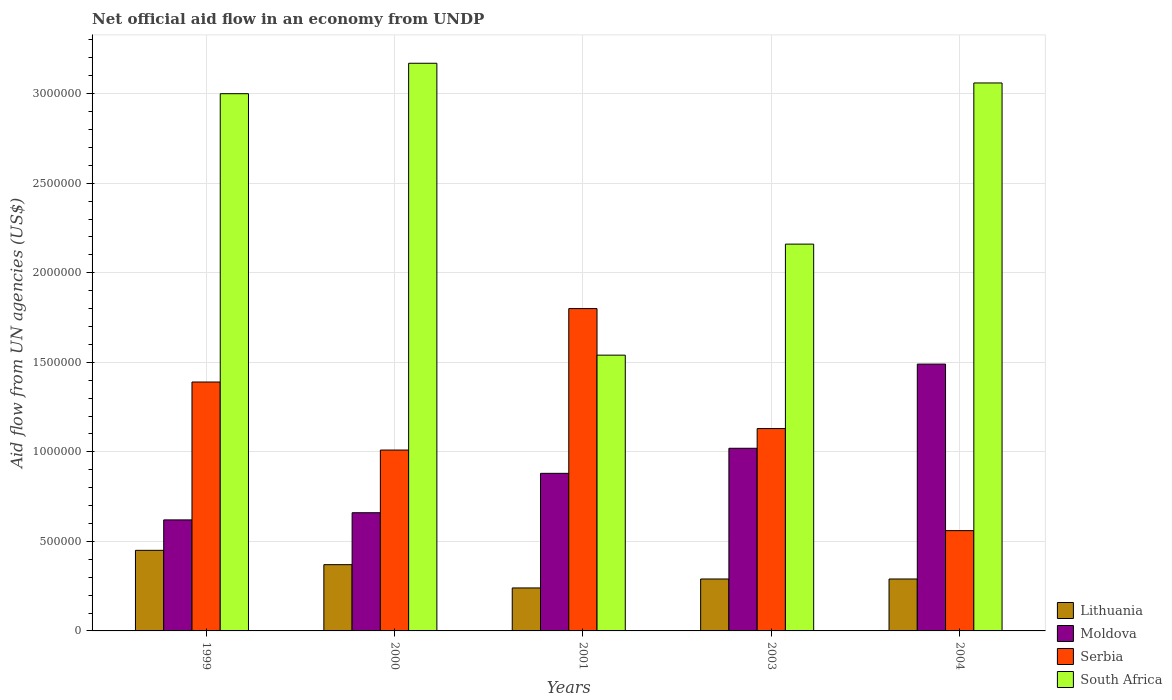How many groups of bars are there?
Ensure brevity in your answer.  5. Are the number of bars per tick equal to the number of legend labels?
Your answer should be compact. Yes. How many bars are there on the 5th tick from the left?
Keep it short and to the point. 4. How many bars are there on the 3rd tick from the right?
Ensure brevity in your answer.  4. What is the net official aid flow in Lithuania in 2003?
Make the answer very short. 2.90e+05. Across all years, what is the maximum net official aid flow in Moldova?
Make the answer very short. 1.49e+06. Across all years, what is the minimum net official aid flow in South Africa?
Your answer should be very brief. 1.54e+06. In which year was the net official aid flow in Lithuania maximum?
Ensure brevity in your answer.  1999. In which year was the net official aid flow in South Africa minimum?
Ensure brevity in your answer.  2001. What is the total net official aid flow in Moldova in the graph?
Your answer should be compact. 4.67e+06. What is the average net official aid flow in Serbia per year?
Provide a succinct answer. 1.18e+06. In the year 2003, what is the difference between the net official aid flow in South Africa and net official aid flow in Lithuania?
Your answer should be compact. 1.87e+06. What is the ratio of the net official aid flow in Lithuania in 2001 to that in 2004?
Offer a terse response. 0.83. Is the net official aid flow in Lithuania in 1999 less than that in 2004?
Give a very brief answer. No. What is the difference between the highest and the lowest net official aid flow in Serbia?
Provide a short and direct response. 1.24e+06. In how many years, is the net official aid flow in Serbia greater than the average net official aid flow in Serbia taken over all years?
Give a very brief answer. 2. What does the 2nd bar from the left in 1999 represents?
Keep it short and to the point. Moldova. What does the 3rd bar from the right in 2004 represents?
Your answer should be very brief. Moldova. Is it the case that in every year, the sum of the net official aid flow in South Africa and net official aid flow in Moldova is greater than the net official aid flow in Serbia?
Keep it short and to the point. Yes. Does the graph contain any zero values?
Your response must be concise. No. Where does the legend appear in the graph?
Keep it short and to the point. Bottom right. How many legend labels are there?
Make the answer very short. 4. What is the title of the graph?
Your response must be concise. Net official aid flow in an economy from UNDP. Does "Europe(all income levels)" appear as one of the legend labels in the graph?
Provide a succinct answer. No. What is the label or title of the Y-axis?
Your response must be concise. Aid flow from UN agencies (US$). What is the Aid flow from UN agencies (US$) in Lithuania in 1999?
Offer a terse response. 4.50e+05. What is the Aid flow from UN agencies (US$) of Moldova in 1999?
Offer a terse response. 6.20e+05. What is the Aid flow from UN agencies (US$) in Serbia in 1999?
Offer a very short reply. 1.39e+06. What is the Aid flow from UN agencies (US$) in Lithuania in 2000?
Keep it short and to the point. 3.70e+05. What is the Aid flow from UN agencies (US$) in Moldova in 2000?
Make the answer very short. 6.60e+05. What is the Aid flow from UN agencies (US$) of Serbia in 2000?
Provide a succinct answer. 1.01e+06. What is the Aid flow from UN agencies (US$) in South Africa in 2000?
Your response must be concise. 3.17e+06. What is the Aid flow from UN agencies (US$) in Lithuania in 2001?
Make the answer very short. 2.40e+05. What is the Aid flow from UN agencies (US$) of Moldova in 2001?
Provide a short and direct response. 8.80e+05. What is the Aid flow from UN agencies (US$) of Serbia in 2001?
Ensure brevity in your answer.  1.80e+06. What is the Aid flow from UN agencies (US$) of South Africa in 2001?
Offer a terse response. 1.54e+06. What is the Aid flow from UN agencies (US$) in Moldova in 2003?
Provide a succinct answer. 1.02e+06. What is the Aid flow from UN agencies (US$) in Serbia in 2003?
Your answer should be compact. 1.13e+06. What is the Aid flow from UN agencies (US$) of South Africa in 2003?
Offer a terse response. 2.16e+06. What is the Aid flow from UN agencies (US$) in Moldova in 2004?
Your response must be concise. 1.49e+06. What is the Aid flow from UN agencies (US$) of Serbia in 2004?
Make the answer very short. 5.60e+05. What is the Aid flow from UN agencies (US$) in South Africa in 2004?
Your answer should be compact. 3.06e+06. Across all years, what is the maximum Aid flow from UN agencies (US$) of Moldova?
Your answer should be compact. 1.49e+06. Across all years, what is the maximum Aid flow from UN agencies (US$) of Serbia?
Your answer should be compact. 1.80e+06. Across all years, what is the maximum Aid flow from UN agencies (US$) of South Africa?
Provide a short and direct response. 3.17e+06. Across all years, what is the minimum Aid flow from UN agencies (US$) in Lithuania?
Ensure brevity in your answer.  2.40e+05. Across all years, what is the minimum Aid flow from UN agencies (US$) of Moldova?
Keep it short and to the point. 6.20e+05. Across all years, what is the minimum Aid flow from UN agencies (US$) in Serbia?
Give a very brief answer. 5.60e+05. Across all years, what is the minimum Aid flow from UN agencies (US$) in South Africa?
Provide a short and direct response. 1.54e+06. What is the total Aid flow from UN agencies (US$) of Lithuania in the graph?
Give a very brief answer. 1.64e+06. What is the total Aid flow from UN agencies (US$) in Moldova in the graph?
Make the answer very short. 4.67e+06. What is the total Aid flow from UN agencies (US$) of Serbia in the graph?
Your answer should be very brief. 5.89e+06. What is the total Aid flow from UN agencies (US$) in South Africa in the graph?
Keep it short and to the point. 1.29e+07. What is the difference between the Aid flow from UN agencies (US$) in Serbia in 1999 and that in 2001?
Offer a very short reply. -4.10e+05. What is the difference between the Aid flow from UN agencies (US$) in South Africa in 1999 and that in 2001?
Provide a succinct answer. 1.46e+06. What is the difference between the Aid flow from UN agencies (US$) in Moldova in 1999 and that in 2003?
Offer a terse response. -4.00e+05. What is the difference between the Aid flow from UN agencies (US$) of South Africa in 1999 and that in 2003?
Give a very brief answer. 8.40e+05. What is the difference between the Aid flow from UN agencies (US$) in Moldova in 1999 and that in 2004?
Provide a succinct answer. -8.70e+05. What is the difference between the Aid flow from UN agencies (US$) of Serbia in 1999 and that in 2004?
Keep it short and to the point. 8.30e+05. What is the difference between the Aid flow from UN agencies (US$) in South Africa in 1999 and that in 2004?
Keep it short and to the point. -6.00e+04. What is the difference between the Aid flow from UN agencies (US$) in Moldova in 2000 and that in 2001?
Provide a short and direct response. -2.20e+05. What is the difference between the Aid flow from UN agencies (US$) in Serbia in 2000 and that in 2001?
Your answer should be very brief. -7.90e+05. What is the difference between the Aid flow from UN agencies (US$) in South Africa in 2000 and that in 2001?
Offer a very short reply. 1.63e+06. What is the difference between the Aid flow from UN agencies (US$) of Lithuania in 2000 and that in 2003?
Provide a succinct answer. 8.00e+04. What is the difference between the Aid flow from UN agencies (US$) in Moldova in 2000 and that in 2003?
Your response must be concise. -3.60e+05. What is the difference between the Aid flow from UN agencies (US$) in Serbia in 2000 and that in 2003?
Provide a short and direct response. -1.20e+05. What is the difference between the Aid flow from UN agencies (US$) in South Africa in 2000 and that in 2003?
Provide a succinct answer. 1.01e+06. What is the difference between the Aid flow from UN agencies (US$) in Moldova in 2000 and that in 2004?
Your answer should be very brief. -8.30e+05. What is the difference between the Aid flow from UN agencies (US$) in Serbia in 2000 and that in 2004?
Offer a very short reply. 4.50e+05. What is the difference between the Aid flow from UN agencies (US$) of South Africa in 2000 and that in 2004?
Provide a short and direct response. 1.10e+05. What is the difference between the Aid flow from UN agencies (US$) in Lithuania in 2001 and that in 2003?
Your answer should be very brief. -5.00e+04. What is the difference between the Aid flow from UN agencies (US$) of Serbia in 2001 and that in 2003?
Your answer should be very brief. 6.70e+05. What is the difference between the Aid flow from UN agencies (US$) of South Africa in 2001 and that in 2003?
Your answer should be compact. -6.20e+05. What is the difference between the Aid flow from UN agencies (US$) of Moldova in 2001 and that in 2004?
Offer a terse response. -6.10e+05. What is the difference between the Aid flow from UN agencies (US$) of Serbia in 2001 and that in 2004?
Your answer should be very brief. 1.24e+06. What is the difference between the Aid flow from UN agencies (US$) of South Africa in 2001 and that in 2004?
Offer a very short reply. -1.52e+06. What is the difference between the Aid flow from UN agencies (US$) in Lithuania in 2003 and that in 2004?
Make the answer very short. 0. What is the difference between the Aid flow from UN agencies (US$) in Moldova in 2003 and that in 2004?
Make the answer very short. -4.70e+05. What is the difference between the Aid flow from UN agencies (US$) of Serbia in 2003 and that in 2004?
Your response must be concise. 5.70e+05. What is the difference between the Aid flow from UN agencies (US$) in South Africa in 2003 and that in 2004?
Offer a very short reply. -9.00e+05. What is the difference between the Aid flow from UN agencies (US$) of Lithuania in 1999 and the Aid flow from UN agencies (US$) of Serbia in 2000?
Keep it short and to the point. -5.60e+05. What is the difference between the Aid flow from UN agencies (US$) of Lithuania in 1999 and the Aid flow from UN agencies (US$) of South Africa in 2000?
Your answer should be compact. -2.72e+06. What is the difference between the Aid flow from UN agencies (US$) in Moldova in 1999 and the Aid flow from UN agencies (US$) in Serbia in 2000?
Ensure brevity in your answer.  -3.90e+05. What is the difference between the Aid flow from UN agencies (US$) of Moldova in 1999 and the Aid flow from UN agencies (US$) of South Africa in 2000?
Offer a terse response. -2.55e+06. What is the difference between the Aid flow from UN agencies (US$) in Serbia in 1999 and the Aid flow from UN agencies (US$) in South Africa in 2000?
Ensure brevity in your answer.  -1.78e+06. What is the difference between the Aid flow from UN agencies (US$) of Lithuania in 1999 and the Aid flow from UN agencies (US$) of Moldova in 2001?
Your response must be concise. -4.30e+05. What is the difference between the Aid flow from UN agencies (US$) of Lithuania in 1999 and the Aid flow from UN agencies (US$) of Serbia in 2001?
Make the answer very short. -1.35e+06. What is the difference between the Aid flow from UN agencies (US$) in Lithuania in 1999 and the Aid flow from UN agencies (US$) in South Africa in 2001?
Your response must be concise. -1.09e+06. What is the difference between the Aid flow from UN agencies (US$) in Moldova in 1999 and the Aid flow from UN agencies (US$) in Serbia in 2001?
Your answer should be compact. -1.18e+06. What is the difference between the Aid flow from UN agencies (US$) of Moldova in 1999 and the Aid flow from UN agencies (US$) of South Africa in 2001?
Your answer should be very brief. -9.20e+05. What is the difference between the Aid flow from UN agencies (US$) of Serbia in 1999 and the Aid flow from UN agencies (US$) of South Africa in 2001?
Offer a very short reply. -1.50e+05. What is the difference between the Aid flow from UN agencies (US$) in Lithuania in 1999 and the Aid flow from UN agencies (US$) in Moldova in 2003?
Your response must be concise. -5.70e+05. What is the difference between the Aid flow from UN agencies (US$) of Lithuania in 1999 and the Aid flow from UN agencies (US$) of Serbia in 2003?
Offer a terse response. -6.80e+05. What is the difference between the Aid flow from UN agencies (US$) of Lithuania in 1999 and the Aid flow from UN agencies (US$) of South Africa in 2003?
Provide a succinct answer. -1.71e+06. What is the difference between the Aid flow from UN agencies (US$) of Moldova in 1999 and the Aid flow from UN agencies (US$) of Serbia in 2003?
Ensure brevity in your answer.  -5.10e+05. What is the difference between the Aid flow from UN agencies (US$) of Moldova in 1999 and the Aid flow from UN agencies (US$) of South Africa in 2003?
Offer a terse response. -1.54e+06. What is the difference between the Aid flow from UN agencies (US$) of Serbia in 1999 and the Aid flow from UN agencies (US$) of South Africa in 2003?
Offer a terse response. -7.70e+05. What is the difference between the Aid flow from UN agencies (US$) of Lithuania in 1999 and the Aid flow from UN agencies (US$) of Moldova in 2004?
Offer a terse response. -1.04e+06. What is the difference between the Aid flow from UN agencies (US$) in Lithuania in 1999 and the Aid flow from UN agencies (US$) in South Africa in 2004?
Your response must be concise. -2.61e+06. What is the difference between the Aid flow from UN agencies (US$) of Moldova in 1999 and the Aid flow from UN agencies (US$) of Serbia in 2004?
Your answer should be compact. 6.00e+04. What is the difference between the Aid flow from UN agencies (US$) of Moldova in 1999 and the Aid flow from UN agencies (US$) of South Africa in 2004?
Your answer should be very brief. -2.44e+06. What is the difference between the Aid flow from UN agencies (US$) of Serbia in 1999 and the Aid flow from UN agencies (US$) of South Africa in 2004?
Your response must be concise. -1.67e+06. What is the difference between the Aid flow from UN agencies (US$) of Lithuania in 2000 and the Aid flow from UN agencies (US$) of Moldova in 2001?
Ensure brevity in your answer.  -5.10e+05. What is the difference between the Aid flow from UN agencies (US$) in Lithuania in 2000 and the Aid flow from UN agencies (US$) in Serbia in 2001?
Your answer should be very brief. -1.43e+06. What is the difference between the Aid flow from UN agencies (US$) in Lithuania in 2000 and the Aid flow from UN agencies (US$) in South Africa in 2001?
Provide a short and direct response. -1.17e+06. What is the difference between the Aid flow from UN agencies (US$) of Moldova in 2000 and the Aid flow from UN agencies (US$) of Serbia in 2001?
Keep it short and to the point. -1.14e+06. What is the difference between the Aid flow from UN agencies (US$) of Moldova in 2000 and the Aid flow from UN agencies (US$) of South Africa in 2001?
Your response must be concise. -8.80e+05. What is the difference between the Aid flow from UN agencies (US$) of Serbia in 2000 and the Aid flow from UN agencies (US$) of South Africa in 2001?
Make the answer very short. -5.30e+05. What is the difference between the Aid flow from UN agencies (US$) in Lithuania in 2000 and the Aid flow from UN agencies (US$) in Moldova in 2003?
Offer a very short reply. -6.50e+05. What is the difference between the Aid flow from UN agencies (US$) in Lithuania in 2000 and the Aid flow from UN agencies (US$) in Serbia in 2003?
Provide a succinct answer. -7.60e+05. What is the difference between the Aid flow from UN agencies (US$) in Lithuania in 2000 and the Aid flow from UN agencies (US$) in South Africa in 2003?
Offer a very short reply. -1.79e+06. What is the difference between the Aid flow from UN agencies (US$) in Moldova in 2000 and the Aid flow from UN agencies (US$) in Serbia in 2003?
Your answer should be compact. -4.70e+05. What is the difference between the Aid flow from UN agencies (US$) in Moldova in 2000 and the Aid flow from UN agencies (US$) in South Africa in 2003?
Provide a succinct answer. -1.50e+06. What is the difference between the Aid flow from UN agencies (US$) of Serbia in 2000 and the Aid flow from UN agencies (US$) of South Africa in 2003?
Provide a succinct answer. -1.15e+06. What is the difference between the Aid flow from UN agencies (US$) of Lithuania in 2000 and the Aid flow from UN agencies (US$) of Moldova in 2004?
Keep it short and to the point. -1.12e+06. What is the difference between the Aid flow from UN agencies (US$) of Lithuania in 2000 and the Aid flow from UN agencies (US$) of Serbia in 2004?
Your answer should be compact. -1.90e+05. What is the difference between the Aid flow from UN agencies (US$) in Lithuania in 2000 and the Aid flow from UN agencies (US$) in South Africa in 2004?
Give a very brief answer. -2.69e+06. What is the difference between the Aid flow from UN agencies (US$) of Moldova in 2000 and the Aid flow from UN agencies (US$) of Serbia in 2004?
Ensure brevity in your answer.  1.00e+05. What is the difference between the Aid flow from UN agencies (US$) in Moldova in 2000 and the Aid flow from UN agencies (US$) in South Africa in 2004?
Ensure brevity in your answer.  -2.40e+06. What is the difference between the Aid flow from UN agencies (US$) in Serbia in 2000 and the Aid flow from UN agencies (US$) in South Africa in 2004?
Keep it short and to the point. -2.05e+06. What is the difference between the Aid flow from UN agencies (US$) of Lithuania in 2001 and the Aid flow from UN agencies (US$) of Moldova in 2003?
Provide a short and direct response. -7.80e+05. What is the difference between the Aid flow from UN agencies (US$) of Lithuania in 2001 and the Aid flow from UN agencies (US$) of Serbia in 2003?
Ensure brevity in your answer.  -8.90e+05. What is the difference between the Aid flow from UN agencies (US$) in Lithuania in 2001 and the Aid flow from UN agencies (US$) in South Africa in 2003?
Give a very brief answer. -1.92e+06. What is the difference between the Aid flow from UN agencies (US$) of Moldova in 2001 and the Aid flow from UN agencies (US$) of South Africa in 2003?
Make the answer very short. -1.28e+06. What is the difference between the Aid flow from UN agencies (US$) of Serbia in 2001 and the Aid flow from UN agencies (US$) of South Africa in 2003?
Your answer should be very brief. -3.60e+05. What is the difference between the Aid flow from UN agencies (US$) in Lithuania in 2001 and the Aid flow from UN agencies (US$) in Moldova in 2004?
Provide a succinct answer. -1.25e+06. What is the difference between the Aid flow from UN agencies (US$) in Lithuania in 2001 and the Aid flow from UN agencies (US$) in Serbia in 2004?
Your answer should be compact. -3.20e+05. What is the difference between the Aid flow from UN agencies (US$) of Lithuania in 2001 and the Aid flow from UN agencies (US$) of South Africa in 2004?
Offer a terse response. -2.82e+06. What is the difference between the Aid flow from UN agencies (US$) of Moldova in 2001 and the Aid flow from UN agencies (US$) of South Africa in 2004?
Your answer should be very brief. -2.18e+06. What is the difference between the Aid flow from UN agencies (US$) of Serbia in 2001 and the Aid flow from UN agencies (US$) of South Africa in 2004?
Your response must be concise. -1.26e+06. What is the difference between the Aid flow from UN agencies (US$) of Lithuania in 2003 and the Aid flow from UN agencies (US$) of Moldova in 2004?
Provide a succinct answer. -1.20e+06. What is the difference between the Aid flow from UN agencies (US$) in Lithuania in 2003 and the Aid flow from UN agencies (US$) in Serbia in 2004?
Your answer should be very brief. -2.70e+05. What is the difference between the Aid flow from UN agencies (US$) in Lithuania in 2003 and the Aid flow from UN agencies (US$) in South Africa in 2004?
Your answer should be compact. -2.77e+06. What is the difference between the Aid flow from UN agencies (US$) of Moldova in 2003 and the Aid flow from UN agencies (US$) of South Africa in 2004?
Offer a terse response. -2.04e+06. What is the difference between the Aid flow from UN agencies (US$) of Serbia in 2003 and the Aid flow from UN agencies (US$) of South Africa in 2004?
Your answer should be compact. -1.93e+06. What is the average Aid flow from UN agencies (US$) of Lithuania per year?
Give a very brief answer. 3.28e+05. What is the average Aid flow from UN agencies (US$) of Moldova per year?
Your response must be concise. 9.34e+05. What is the average Aid flow from UN agencies (US$) of Serbia per year?
Your answer should be compact. 1.18e+06. What is the average Aid flow from UN agencies (US$) of South Africa per year?
Offer a very short reply. 2.59e+06. In the year 1999, what is the difference between the Aid flow from UN agencies (US$) in Lithuania and Aid flow from UN agencies (US$) in Serbia?
Offer a terse response. -9.40e+05. In the year 1999, what is the difference between the Aid flow from UN agencies (US$) in Lithuania and Aid flow from UN agencies (US$) in South Africa?
Make the answer very short. -2.55e+06. In the year 1999, what is the difference between the Aid flow from UN agencies (US$) of Moldova and Aid flow from UN agencies (US$) of Serbia?
Your answer should be very brief. -7.70e+05. In the year 1999, what is the difference between the Aid flow from UN agencies (US$) of Moldova and Aid flow from UN agencies (US$) of South Africa?
Your answer should be compact. -2.38e+06. In the year 1999, what is the difference between the Aid flow from UN agencies (US$) of Serbia and Aid flow from UN agencies (US$) of South Africa?
Keep it short and to the point. -1.61e+06. In the year 2000, what is the difference between the Aid flow from UN agencies (US$) of Lithuania and Aid flow from UN agencies (US$) of Serbia?
Make the answer very short. -6.40e+05. In the year 2000, what is the difference between the Aid flow from UN agencies (US$) in Lithuania and Aid flow from UN agencies (US$) in South Africa?
Make the answer very short. -2.80e+06. In the year 2000, what is the difference between the Aid flow from UN agencies (US$) of Moldova and Aid flow from UN agencies (US$) of Serbia?
Your answer should be compact. -3.50e+05. In the year 2000, what is the difference between the Aid flow from UN agencies (US$) in Moldova and Aid flow from UN agencies (US$) in South Africa?
Ensure brevity in your answer.  -2.51e+06. In the year 2000, what is the difference between the Aid flow from UN agencies (US$) of Serbia and Aid flow from UN agencies (US$) of South Africa?
Your answer should be compact. -2.16e+06. In the year 2001, what is the difference between the Aid flow from UN agencies (US$) of Lithuania and Aid flow from UN agencies (US$) of Moldova?
Your answer should be compact. -6.40e+05. In the year 2001, what is the difference between the Aid flow from UN agencies (US$) of Lithuania and Aid flow from UN agencies (US$) of Serbia?
Offer a terse response. -1.56e+06. In the year 2001, what is the difference between the Aid flow from UN agencies (US$) in Lithuania and Aid flow from UN agencies (US$) in South Africa?
Your response must be concise. -1.30e+06. In the year 2001, what is the difference between the Aid flow from UN agencies (US$) of Moldova and Aid flow from UN agencies (US$) of Serbia?
Keep it short and to the point. -9.20e+05. In the year 2001, what is the difference between the Aid flow from UN agencies (US$) of Moldova and Aid flow from UN agencies (US$) of South Africa?
Your answer should be compact. -6.60e+05. In the year 2001, what is the difference between the Aid flow from UN agencies (US$) of Serbia and Aid flow from UN agencies (US$) of South Africa?
Give a very brief answer. 2.60e+05. In the year 2003, what is the difference between the Aid flow from UN agencies (US$) of Lithuania and Aid flow from UN agencies (US$) of Moldova?
Give a very brief answer. -7.30e+05. In the year 2003, what is the difference between the Aid flow from UN agencies (US$) in Lithuania and Aid flow from UN agencies (US$) in Serbia?
Give a very brief answer. -8.40e+05. In the year 2003, what is the difference between the Aid flow from UN agencies (US$) in Lithuania and Aid flow from UN agencies (US$) in South Africa?
Give a very brief answer. -1.87e+06. In the year 2003, what is the difference between the Aid flow from UN agencies (US$) in Moldova and Aid flow from UN agencies (US$) in Serbia?
Make the answer very short. -1.10e+05. In the year 2003, what is the difference between the Aid flow from UN agencies (US$) in Moldova and Aid flow from UN agencies (US$) in South Africa?
Provide a succinct answer. -1.14e+06. In the year 2003, what is the difference between the Aid flow from UN agencies (US$) in Serbia and Aid flow from UN agencies (US$) in South Africa?
Provide a short and direct response. -1.03e+06. In the year 2004, what is the difference between the Aid flow from UN agencies (US$) of Lithuania and Aid flow from UN agencies (US$) of Moldova?
Ensure brevity in your answer.  -1.20e+06. In the year 2004, what is the difference between the Aid flow from UN agencies (US$) in Lithuania and Aid flow from UN agencies (US$) in Serbia?
Ensure brevity in your answer.  -2.70e+05. In the year 2004, what is the difference between the Aid flow from UN agencies (US$) in Lithuania and Aid flow from UN agencies (US$) in South Africa?
Your answer should be very brief. -2.77e+06. In the year 2004, what is the difference between the Aid flow from UN agencies (US$) in Moldova and Aid flow from UN agencies (US$) in Serbia?
Provide a short and direct response. 9.30e+05. In the year 2004, what is the difference between the Aid flow from UN agencies (US$) in Moldova and Aid flow from UN agencies (US$) in South Africa?
Offer a terse response. -1.57e+06. In the year 2004, what is the difference between the Aid flow from UN agencies (US$) of Serbia and Aid flow from UN agencies (US$) of South Africa?
Give a very brief answer. -2.50e+06. What is the ratio of the Aid flow from UN agencies (US$) in Lithuania in 1999 to that in 2000?
Your answer should be compact. 1.22. What is the ratio of the Aid flow from UN agencies (US$) in Moldova in 1999 to that in 2000?
Provide a succinct answer. 0.94. What is the ratio of the Aid flow from UN agencies (US$) in Serbia in 1999 to that in 2000?
Provide a short and direct response. 1.38. What is the ratio of the Aid flow from UN agencies (US$) in South Africa in 1999 to that in 2000?
Offer a very short reply. 0.95. What is the ratio of the Aid flow from UN agencies (US$) in Lithuania in 1999 to that in 2001?
Give a very brief answer. 1.88. What is the ratio of the Aid flow from UN agencies (US$) in Moldova in 1999 to that in 2001?
Offer a terse response. 0.7. What is the ratio of the Aid flow from UN agencies (US$) in Serbia in 1999 to that in 2001?
Your response must be concise. 0.77. What is the ratio of the Aid flow from UN agencies (US$) in South Africa in 1999 to that in 2001?
Offer a terse response. 1.95. What is the ratio of the Aid flow from UN agencies (US$) of Lithuania in 1999 to that in 2003?
Keep it short and to the point. 1.55. What is the ratio of the Aid flow from UN agencies (US$) of Moldova in 1999 to that in 2003?
Ensure brevity in your answer.  0.61. What is the ratio of the Aid flow from UN agencies (US$) of Serbia in 1999 to that in 2003?
Provide a succinct answer. 1.23. What is the ratio of the Aid flow from UN agencies (US$) of South Africa in 1999 to that in 2003?
Offer a very short reply. 1.39. What is the ratio of the Aid flow from UN agencies (US$) of Lithuania in 1999 to that in 2004?
Offer a terse response. 1.55. What is the ratio of the Aid flow from UN agencies (US$) in Moldova in 1999 to that in 2004?
Make the answer very short. 0.42. What is the ratio of the Aid flow from UN agencies (US$) of Serbia in 1999 to that in 2004?
Your answer should be compact. 2.48. What is the ratio of the Aid flow from UN agencies (US$) of South Africa in 1999 to that in 2004?
Offer a very short reply. 0.98. What is the ratio of the Aid flow from UN agencies (US$) of Lithuania in 2000 to that in 2001?
Provide a succinct answer. 1.54. What is the ratio of the Aid flow from UN agencies (US$) of Moldova in 2000 to that in 2001?
Your answer should be very brief. 0.75. What is the ratio of the Aid flow from UN agencies (US$) in Serbia in 2000 to that in 2001?
Provide a short and direct response. 0.56. What is the ratio of the Aid flow from UN agencies (US$) of South Africa in 2000 to that in 2001?
Keep it short and to the point. 2.06. What is the ratio of the Aid flow from UN agencies (US$) of Lithuania in 2000 to that in 2003?
Provide a short and direct response. 1.28. What is the ratio of the Aid flow from UN agencies (US$) in Moldova in 2000 to that in 2003?
Provide a short and direct response. 0.65. What is the ratio of the Aid flow from UN agencies (US$) of Serbia in 2000 to that in 2003?
Give a very brief answer. 0.89. What is the ratio of the Aid flow from UN agencies (US$) in South Africa in 2000 to that in 2003?
Provide a short and direct response. 1.47. What is the ratio of the Aid flow from UN agencies (US$) in Lithuania in 2000 to that in 2004?
Offer a terse response. 1.28. What is the ratio of the Aid flow from UN agencies (US$) of Moldova in 2000 to that in 2004?
Make the answer very short. 0.44. What is the ratio of the Aid flow from UN agencies (US$) in Serbia in 2000 to that in 2004?
Your response must be concise. 1.8. What is the ratio of the Aid flow from UN agencies (US$) in South Africa in 2000 to that in 2004?
Offer a very short reply. 1.04. What is the ratio of the Aid flow from UN agencies (US$) in Lithuania in 2001 to that in 2003?
Provide a short and direct response. 0.83. What is the ratio of the Aid flow from UN agencies (US$) of Moldova in 2001 to that in 2003?
Offer a terse response. 0.86. What is the ratio of the Aid flow from UN agencies (US$) in Serbia in 2001 to that in 2003?
Keep it short and to the point. 1.59. What is the ratio of the Aid flow from UN agencies (US$) in South Africa in 2001 to that in 2003?
Provide a succinct answer. 0.71. What is the ratio of the Aid flow from UN agencies (US$) of Lithuania in 2001 to that in 2004?
Ensure brevity in your answer.  0.83. What is the ratio of the Aid flow from UN agencies (US$) in Moldova in 2001 to that in 2004?
Your answer should be compact. 0.59. What is the ratio of the Aid flow from UN agencies (US$) in Serbia in 2001 to that in 2004?
Ensure brevity in your answer.  3.21. What is the ratio of the Aid flow from UN agencies (US$) of South Africa in 2001 to that in 2004?
Offer a terse response. 0.5. What is the ratio of the Aid flow from UN agencies (US$) in Moldova in 2003 to that in 2004?
Your response must be concise. 0.68. What is the ratio of the Aid flow from UN agencies (US$) of Serbia in 2003 to that in 2004?
Your answer should be compact. 2.02. What is the ratio of the Aid flow from UN agencies (US$) of South Africa in 2003 to that in 2004?
Your response must be concise. 0.71. What is the difference between the highest and the second highest Aid flow from UN agencies (US$) of Serbia?
Offer a terse response. 4.10e+05. What is the difference between the highest and the second highest Aid flow from UN agencies (US$) of South Africa?
Make the answer very short. 1.10e+05. What is the difference between the highest and the lowest Aid flow from UN agencies (US$) of Lithuania?
Offer a very short reply. 2.10e+05. What is the difference between the highest and the lowest Aid flow from UN agencies (US$) of Moldova?
Offer a terse response. 8.70e+05. What is the difference between the highest and the lowest Aid flow from UN agencies (US$) in Serbia?
Offer a terse response. 1.24e+06. What is the difference between the highest and the lowest Aid flow from UN agencies (US$) of South Africa?
Provide a succinct answer. 1.63e+06. 